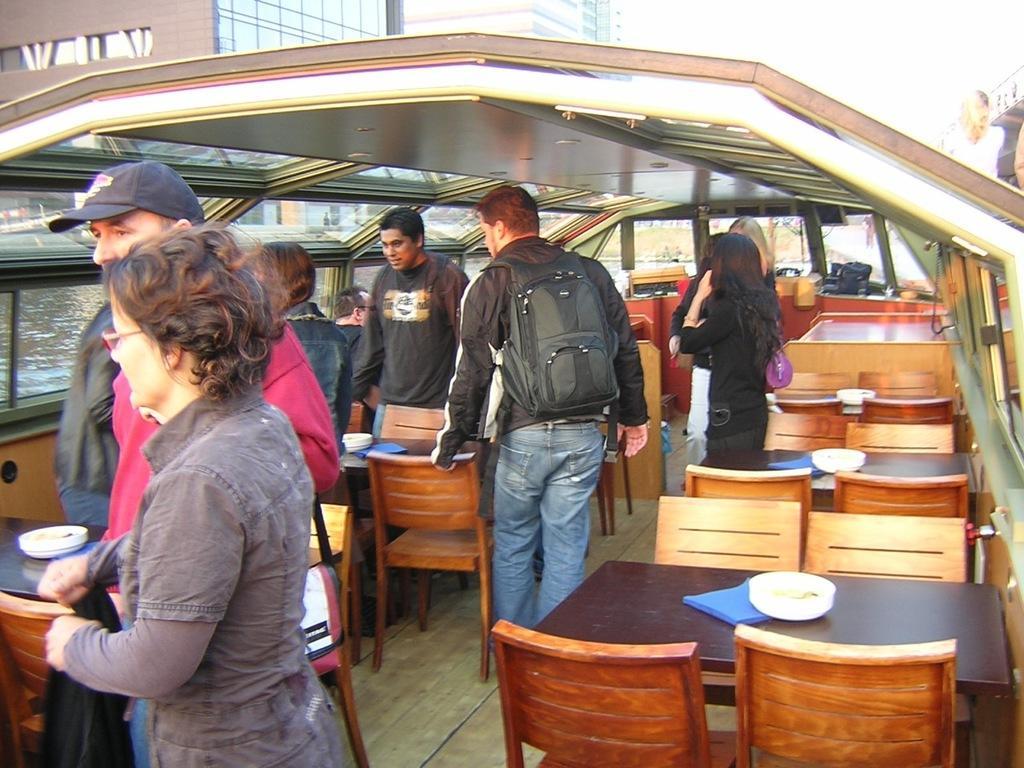In one or two sentences, can you explain what this image depicts? In this image, there are some persons wearing colorful clothes and standing in a boat. There are some table and chairs in a boat. This person wearing a bag. This person wearing a cap on his head. There is a building at the top left. 